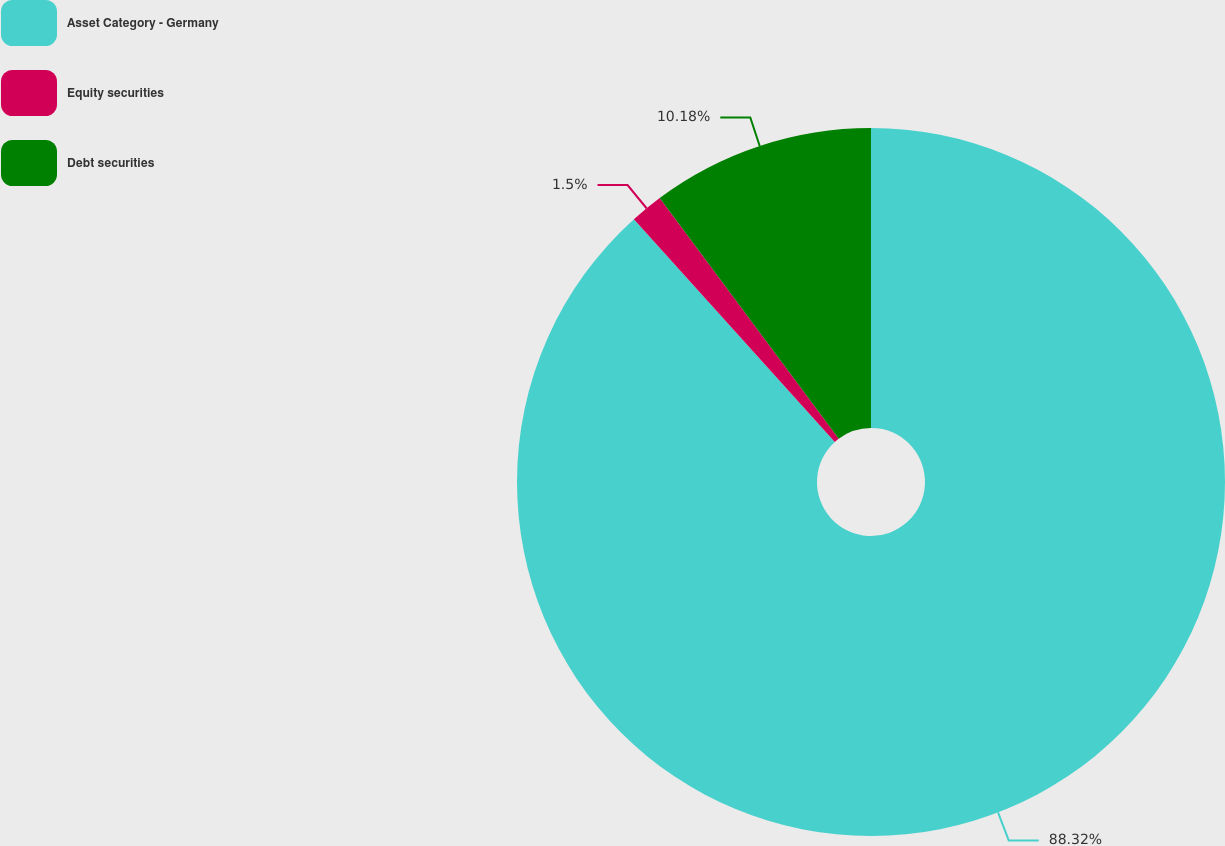Convert chart. <chart><loc_0><loc_0><loc_500><loc_500><pie_chart><fcel>Asset Category - Germany<fcel>Equity securities<fcel>Debt securities<nl><fcel>88.32%<fcel>1.5%<fcel>10.18%<nl></chart> 